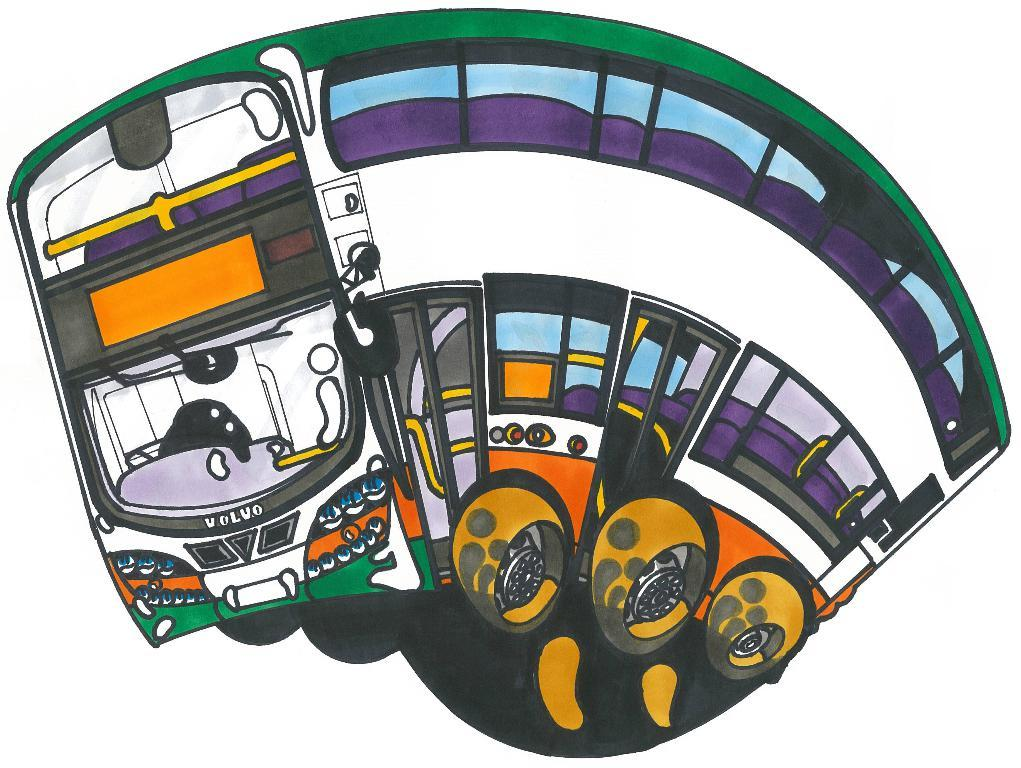What is the main subject of the image? There is a depiction of a bus in the image. What color is the background of the image? The background of the image is white. What type of cast can be seen on the bus driver's arm in the image? There is no cast visible on the bus driver's arm in the image, as there is no bus driver or arm depicted. 